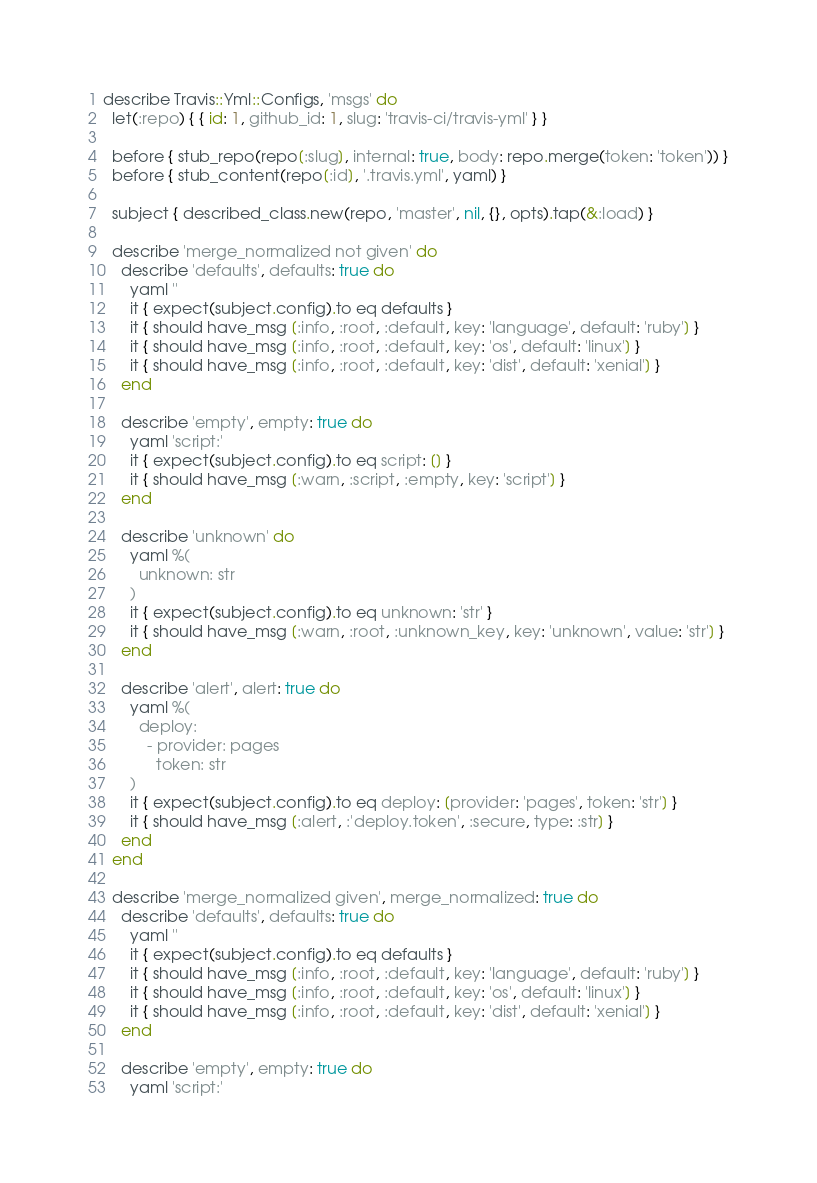Convert code to text. <code><loc_0><loc_0><loc_500><loc_500><_Ruby_>describe Travis::Yml::Configs, 'msgs' do
  let(:repo) { { id: 1, github_id: 1, slug: 'travis-ci/travis-yml' } }

  before { stub_repo(repo[:slug], internal: true, body: repo.merge(token: 'token')) }
  before { stub_content(repo[:id], '.travis.yml', yaml) }

  subject { described_class.new(repo, 'master', nil, {}, opts).tap(&:load) }

  describe 'merge_normalized not given' do
    describe 'defaults', defaults: true do
      yaml ''
      it { expect(subject.config).to eq defaults }
      it { should have_msg [:info, :root, :default, key: 'language', default: 'ruby'] }
      it { should have_msg [:info, :root, :default, key: 'os', default: 'linux'] }
      it { should have_msg [:info, :root, :default, key: 'dist', default: 'xenial'] }
    end

    describe 'empty', empty: true do
      yaml 'script:'
      it { expect(subject.config).to eq script: [] }
      it { should have_msg [:warn, :script, :empty, key: 'script'] }
    end

    describe 'unknown' do
      yaml %(
        unknown: str
      )
      it { expect(subject.config).to eq unknown: 'str' }
      it { should have_msg [:warn, :root, :unknown_key, key: 'unknown', value: 'str'] }
    end

    describe 'alert', alert: true do
      yaml %(
        deploy:
          - provider: pages
            token: str
      )
      it { expect(subject.config).to eq deploy: [provider: 'pages', token: 'str'] }
      it { should have_msg [:alert, :'deploy.token', :secure, type: :str] }
    end
  end

  describe 'merge_normalized given', merge_normalized: true do
    describe 'defaults', defaults: true do
      yaml ''
      it { expect(subject.config).to eq defaults }
      it { should have_msg [:info, :root, :default, key: 'language', default: 'ruby'] }
      it { should have_msg [:info, :root, :default, key: 'os', default: 'linux'] }
      it { should have_msg [:info, :root, :default, key: 'dist', default: 'xenial'] }
    end

    describe 'empty', empty: true do
      yaml 'script:'</code> 